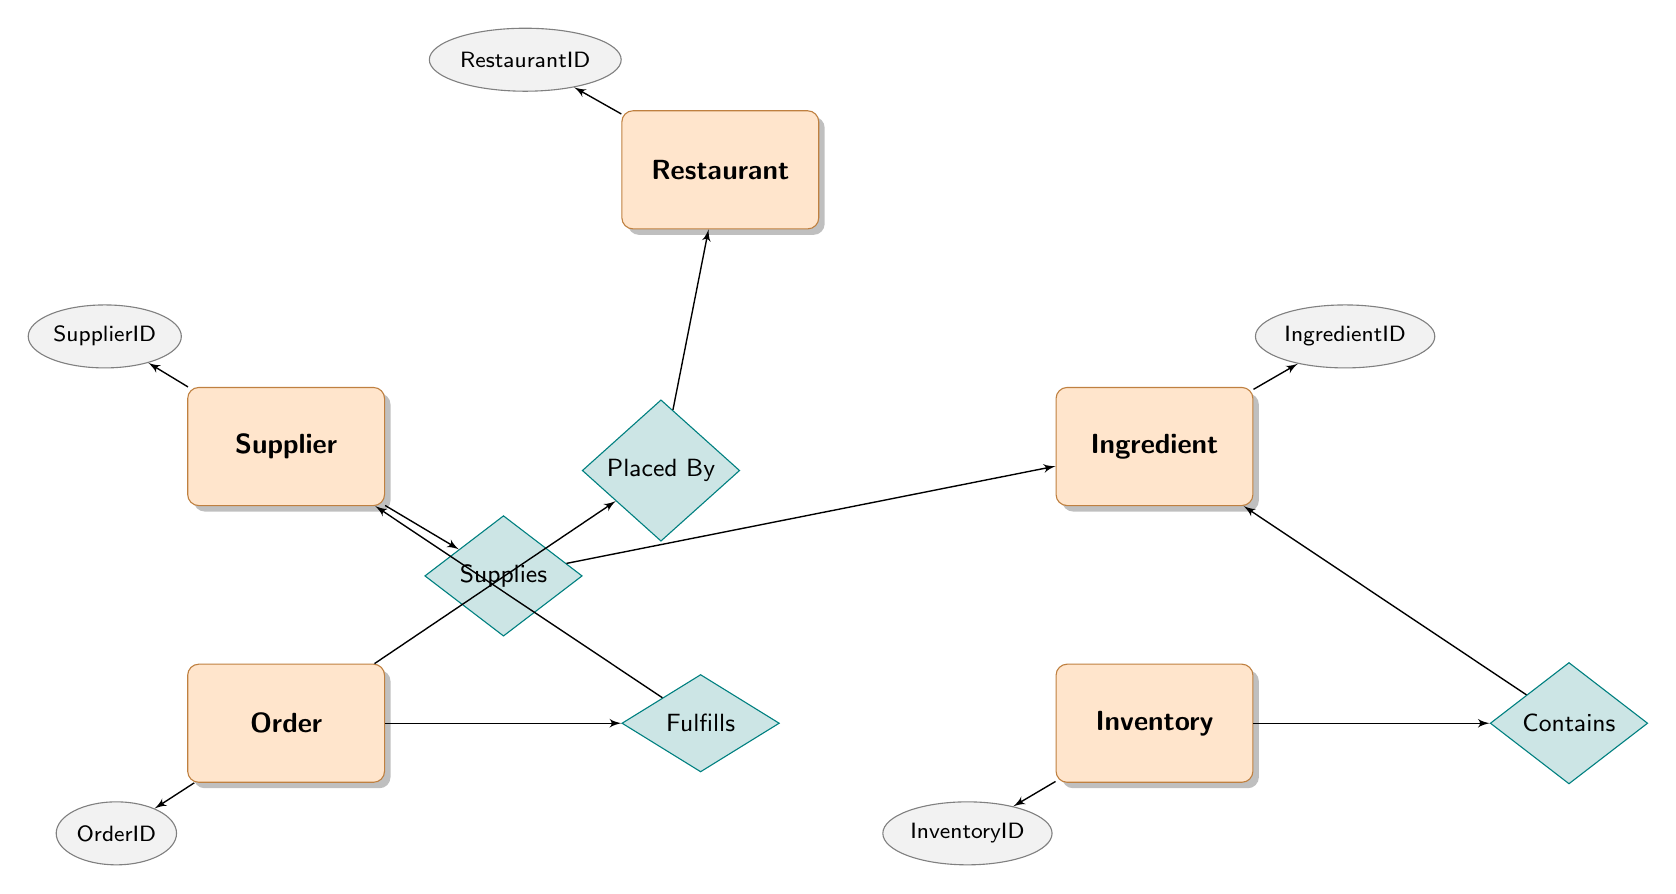What entities are represented in the diagram? The diagram includes the entities Restaurant, Supplier, Ingredient, Inventory, and Order. By looking at the nodes labeled as entities, we can clearly see that these five entities are present.
Answer: Restaurant, Supplier, Ingredient, Inventory, Order How many relationships are there in the diagram? The diagram shows four relationships: Supplies, Contains, Placed By, and Fulfills. By counting the diamond-shaped nodes labeled as relationships, we find a total of four.
Answer: 4 What is the attribute of the Supplier entity? The Supplier entity has the attributes SupplierID, Name, Contact, and Location. This can be identified by checking the attributes listed next to the Supplier entity node.
Answer: SupplierID, Name, Contact, Location Which relationship connects Order to Restaurant? The relationship that connects Order to Restaurant is Placed By. By tracing the connection from the Order node to the diamond labeled as Placed By, we confirm this relationship.
Answer: Placed By What is the attribute of the Inventory entity? The Inventory entity has the attribute InventoryID, Quantity, and DateReceived. We can see this by looking at the attributes listed near the Inventory entity node and identifying them.
Answer: InventoryID, Quantity, DateReceived How does an Order relate to a Supplier? An Order relates to a Supplier through the Fulfills relationship, which is represented by the connection between the Order node and the Supplier node through the Fulfills diamond.
Answer: Fulfills What kind of ingredient can a Supplier supply? A Supplier can supply an Ingredient with a SupplyRate, as indicated by the Supplies relationship. We see the connection linking the Supplier node with the Ingredient node, specifying the nature of their interaction.
Answer: Ingredient with SupplyRate Which entity does the Contains relationship involve? The Contains relationship involves both Inventory and Ingredient entities. By examining the diamond labeled as Contains, we note that it connects the Inventory node and the Ingredient node.
Answer: Inventory, Ingredient What is required for placing an Order? An Order must be Placed By a Restaurant, as depicted in the relationship connecting the Order node to the Restaurant node through the diamond labeled as Placed By.
Answer: Restaurant 